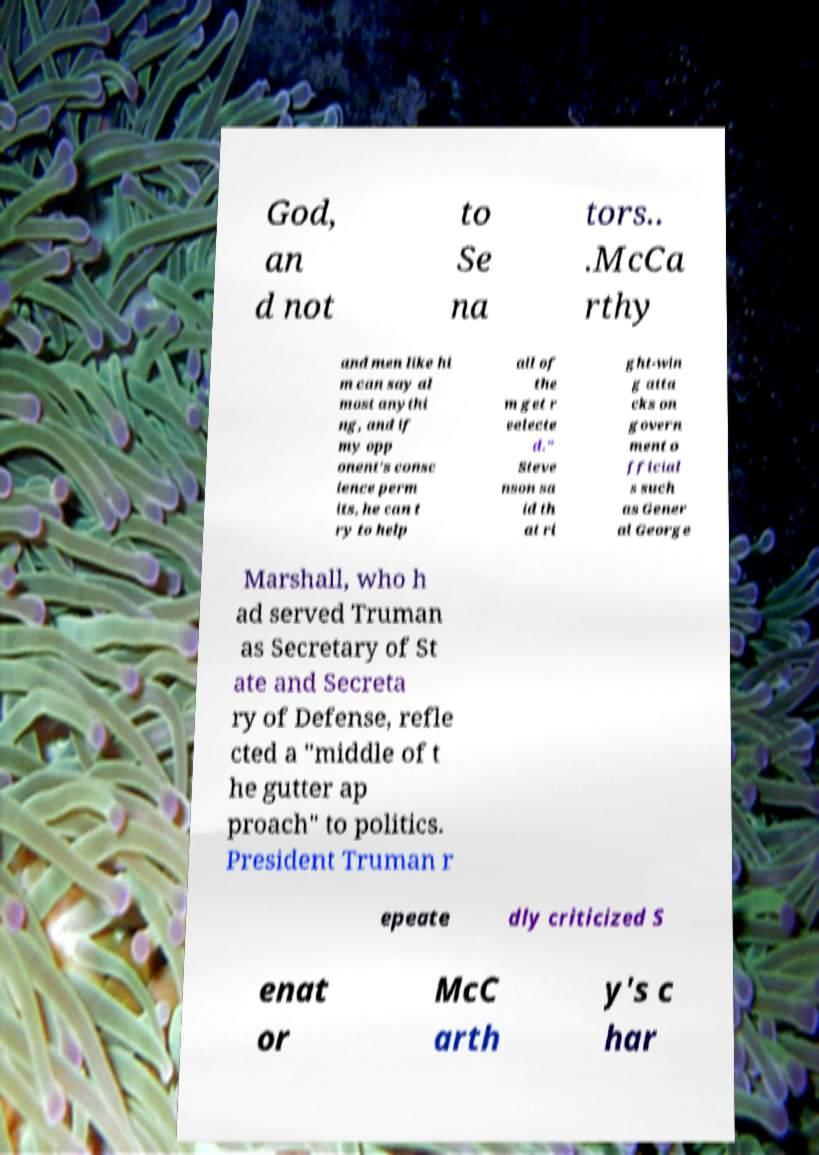Could you extract and type out the text from this image? God, an d not to Se na tors.. .McCa rthy and men like hi m can say al most anythi ng, and if my opp onent's consc ience perm its, he can t ry to help all of the m get r eelecte d." Steve nson sa id th at ri ght-win g atta cks on govern ment o fficial s such as Gener al George Marshall, who h ad served Truman as Secretary of St ate and Secreta ry of Defense, refle cted a "middle of t he gutter ap proach" to politics. President Truman r epeate dly criticized S enat or McC arth y's c har 